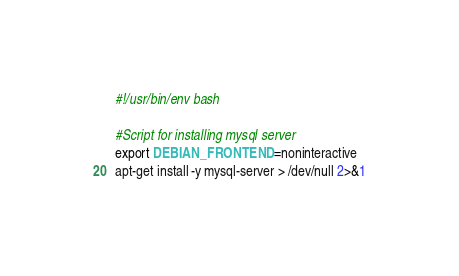<code> <loc_0><loc_0><loc_500><loc_500><_Bash_>#!/usr/bin/env bash

#Script for installing mysql server
export DEBIAN_FRONTEND=noninteractive
apt-get install -y mysql-server > /dev/null 2>&1
</code> 